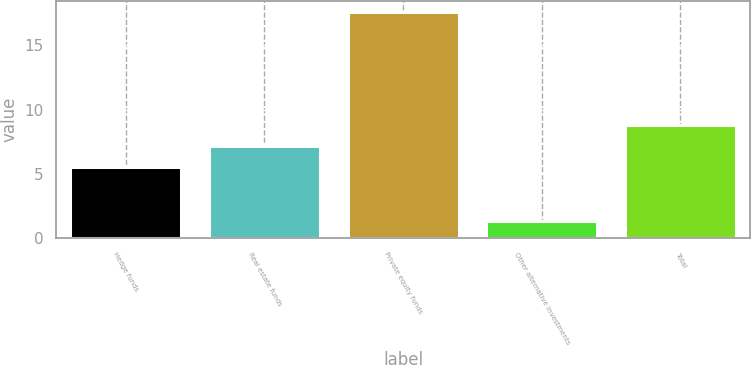<chart> <loc_0><loc_0><loc_500><loc_500><bar_chart><fcel>Hedge funds<fcel>Real estate funds<fcel>Private equity funds<fcel>Other alternative investments<fcel>Total<nl><fcel>5.5<fcel>7.2<fcel>17.6<fcel>1.3<fcel>8.83<nl></chart> 